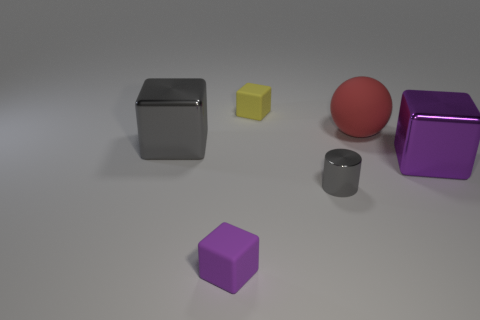What number of small things are either brown blocks or red matte things?
Make the answer very short. 0. How many metallic blocks are left of the gray cube?
Ensure brevity in your answer.  0. Are there any other tiny metal cylinders that have the same color as the cylinder?
Provide a short and direct response. No. There is a gray thing that is the same size as the purple rubber cube; what shape is it?
Keep it short and to the point. Cylinder. How many gray objects are either small matte blocks or big metal cylinders?
Provide a succinct answer. 0. What number of yellow things have the same size as the gray cylinder?
Keep it short and to the point. 1. How many objects are either small cyan cubes or large purple things in front of the large ball?
Ensure brevity in your answer.  1. There is a matte thing in front of the gray metal cube; is it the same size as the rubber cube behind the big red matte sphere?
Provide a short and direct response. Yes. What number of other large things are the same shape as the yellow object?
Make the answer very short. 2. What is the shape of the other gray thing that is made of the same material as the big gray object?
Give a very brief answer. Cylinder. 